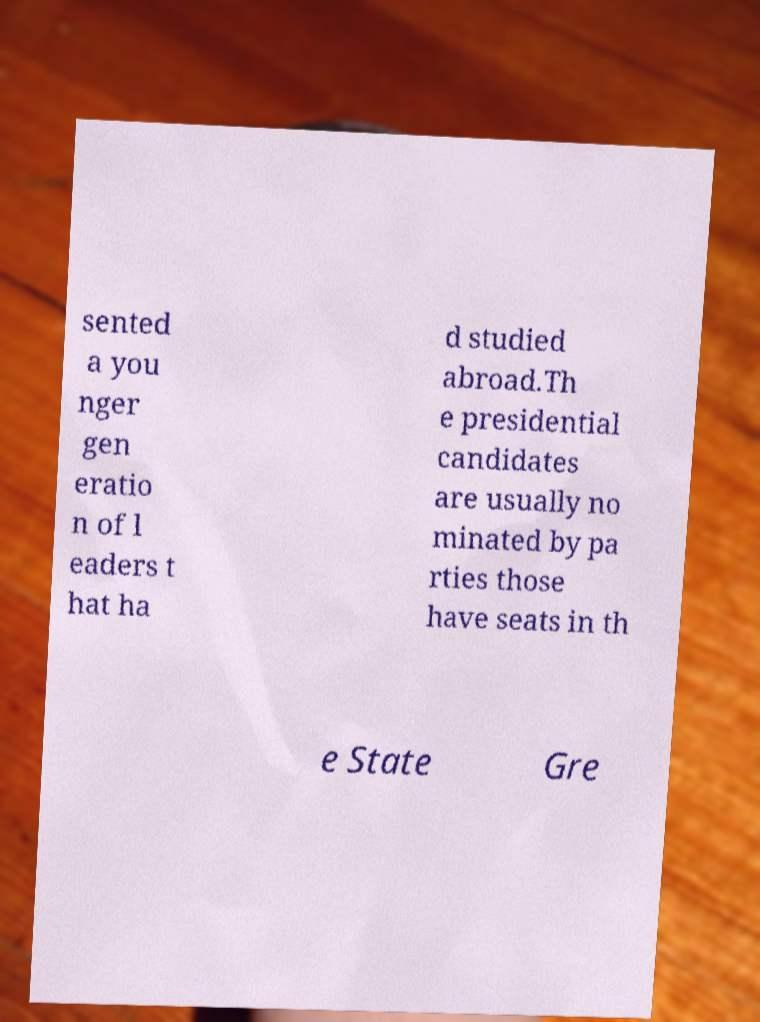Can you accurately transcribe the text from the provided image for me? sented a you nger gen eratio n of l eaders t hat ha d studied abroad.Th e presidential candidates are usually no minated by pa rties those have seats in th e State Gre 